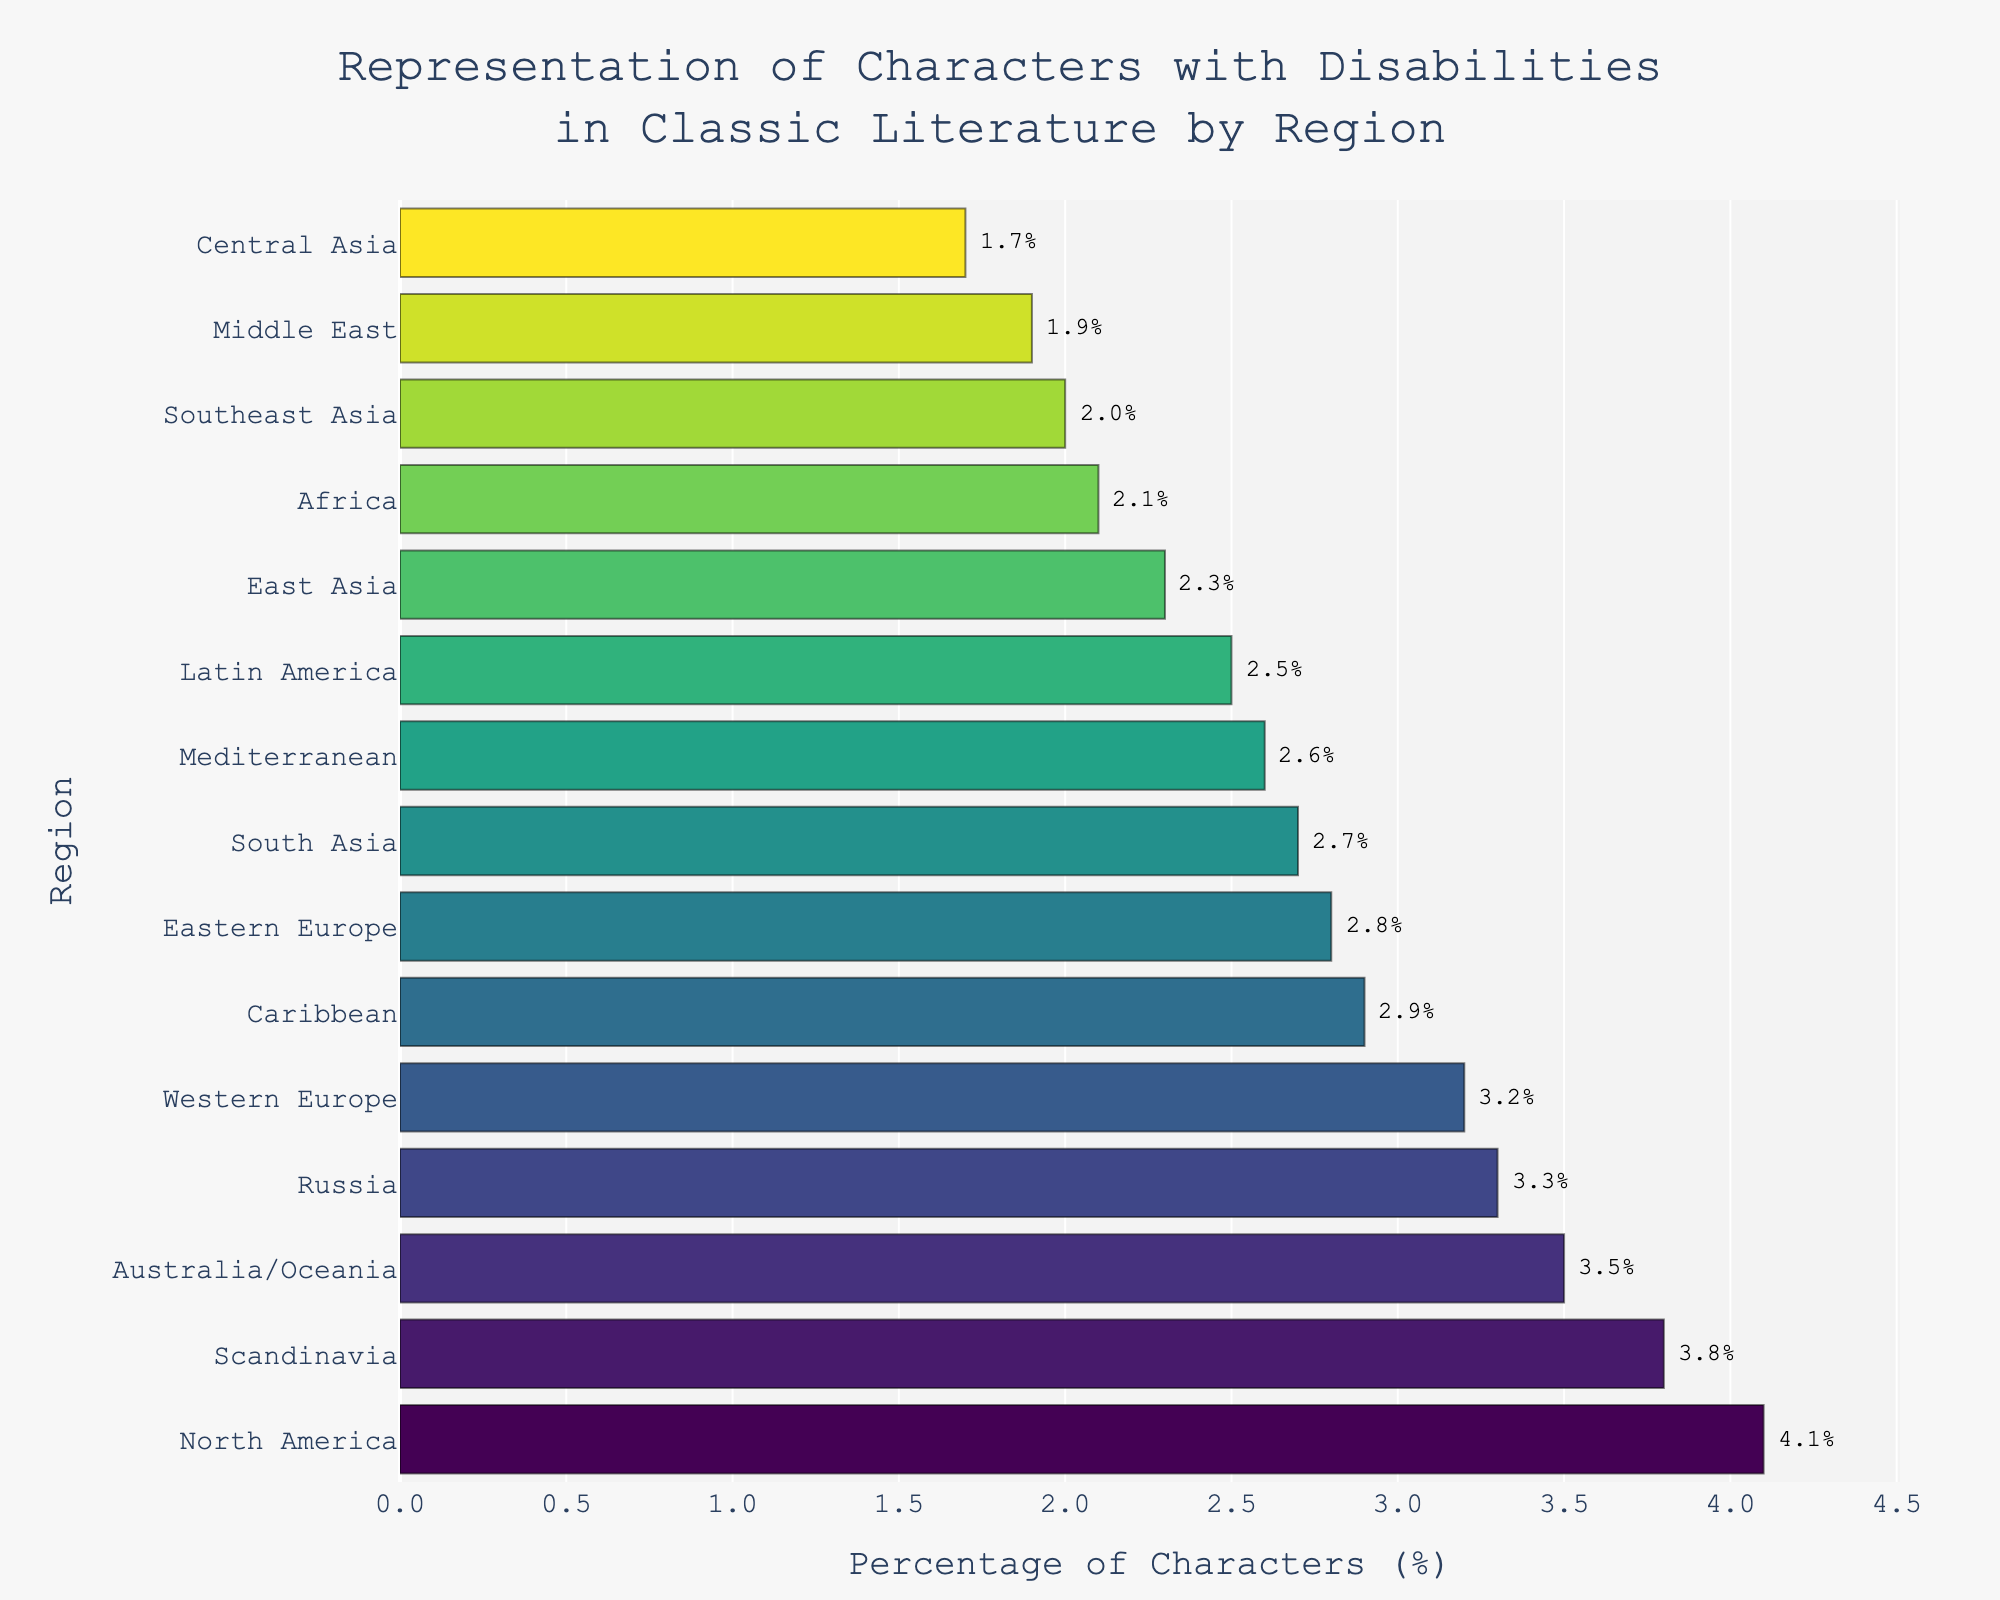What's the region with the highest percentage of characters with disabilities? Look for the bar that extends the farthest to the right. In this case, it is Scandinavia.
Answer: Scandinavia Which two regions have the closest percentages of characters with disabilities? Compare the lengths of the bars that are very close in length. Western Europe and Russia both have percentages around 3.2% and 3.3% respectively.
Answer: Western Europe and Russia What's the difference in the percentage of characters with disabilities between the region with the highest representation and the region with the lowest representation? Identify the percentage for Scandinavia (3.8%) and Central Asia (1.7%). Subtract the two: 3.8% - 1.7%.
Answer: 2.1% How many regions have a percentage of characters with disabilities greater than 3%? Count the regions whose bars extend past the 3% mark: North America, Western Europe, Scandinavia, Russia, and Australia/Oceania.
Answer: 5 Which regions have percentages below 2%? Identify and list regions where the bars are below the 2% mark: Middle East and Central Asia.
Answer: Middle East and Central Asia Compare the representation of characters with disabilities between North America and the Mediterranean region. Look at the lengths of the bars for North America (4.1%) and Mediterranean (2.6%), then compare them.
Answer: North America has a higher percentage What's the average percentage of characters with disabilities in the Caribbean and Latin America? Add the percentages: 2.9% + 2.5%, then divide by 2. (2.9% + 2.5%) / 2 = 2.7%
Answer: 2.7% How does the representation of characters with disabilities in Africa compare to East Asia? Look at their respective percentages: Africa (2.1%) and East Asia (2.3%), and note that East Asia has a slightly higher percentage than Africa.
Answer: East Asia has a slightly higher percentage Which region in Asia has the highest percentage of characters with disabilities? Compare percentages for East Asia, South Asia, Central Asia, and Southeast Asia. East Asia has the highest with 2.3%.
Answer: East Asia What is the combined percentage of characters with disabilities for Eastern Europe and South Asia? Sum the percentages of Eastern Europe (2.8%) and South Asia (2.7%): 2.8% + 2.7% = 5.5%.
Answer: 5.5% 